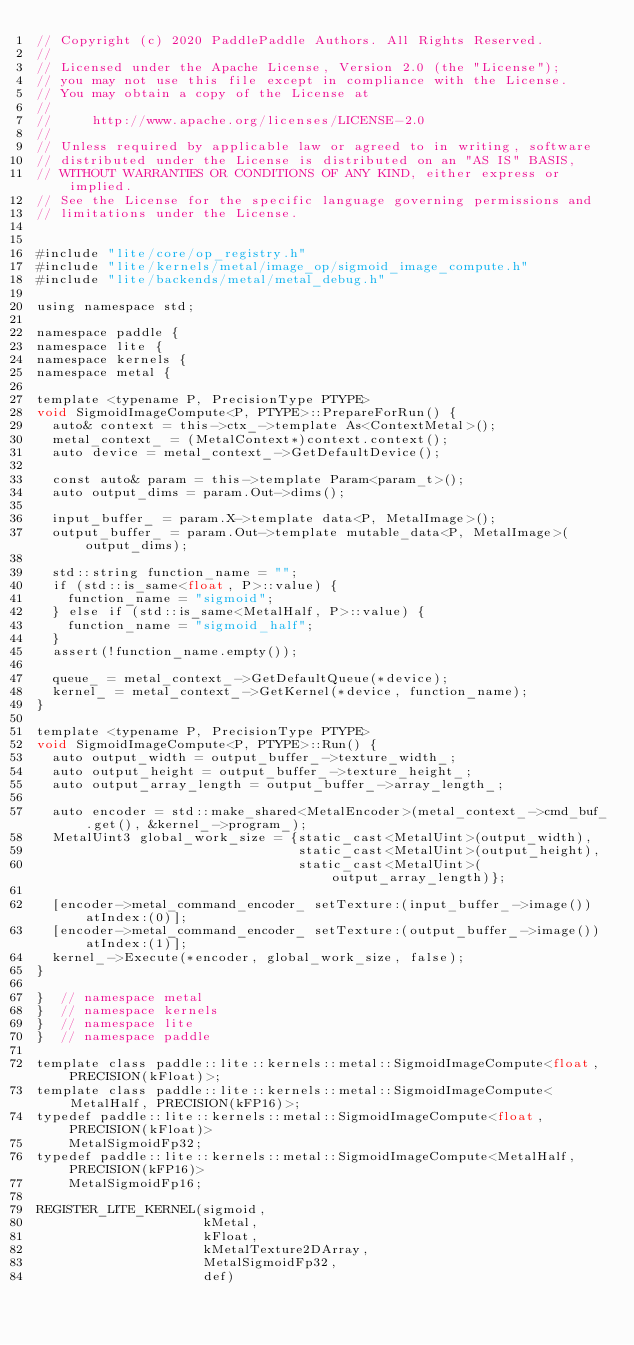<code> <loc_0><loc_0><loc_500><loc_500><_ObjectiveC_>// Copyright (c) 2020 PaddlePaddle Authors. All Rights Reserved.
//
// Licensed under the Apache License, Version 2.0 (the "License");
// you may not use this file except in compliance with the License.
// You may obtain a copy of the License at
//
//     http://www.apache.org/licenses/LICENSE-2.0
//
// Unless required by applicable law or agreed to in writing, software
// distributed under the License is distributed on an "AS IS" BASIS,
// WITHOUT WARRANTIES OR CONDITIONS OF ANY KIND, either express or implied.
// See the License for the specific language governing permissions and
// limitations under the License.


#include "lite/core/op_registry.h"
#include "lite/kernels/metal/image_op/sigmoid_image_compute.h"
#include "lite/backends/metal/metal_debug.h"

using namespace std;

namespace paddle {
namespace lite {
namespace kernels {
namespace metal {

template <typename P, PrecisionType PTYPE>
void SigmoidImageCompute<P, PTYPE>::PrepareForRun() {
  auto& context = this->ctx_->template As<ContextMetal>();
  metal_context_ = (MetalContext*)context.context();
  auto device = metal_context_->GetDefaultDevice();

  const auto& param = this->template Param<param_t>();
  auto output_dims = param.Out->dims();

  input_buffer_ = param.X->template data<P, MetalImage>();
  output_buffer_ = param.Out->template mutable_data<P, MetalImage>(output_dims);

  std::string function_name = "";
  if (std::is_same<float, P>::value) {
    function_name = "sigmoid";
  } else if (std::is_same<MetalHalf, P>::value) {
    function_name = "sigmoid_half";
  }
  assert(!function_name.empty());

  queue_ = metal_context_->GetDefaultQueue(*device);
  kernel_ = metal_context_->GetKernel(*device, function_name);
}

template <typename P, PrecisionType PTYPE>
void SigmoidImageCompute<P, PTYPE>::Run() {
  auto output_width = output_buffer_->texture_width_;
  auto output_height = output_buffer_->texture_height_;
  auto output_array_length = output_buffer_->array_length_;

  auto encoder = std::make_shared<MetalEncoder>(metal_context_->cmd_buf_.get(), &kernel_->program_);
  MetalUint3 global_work_size = {static_cast<MetalUint>(output_width),
                                 static_cast<MetalUint>(output_height),
                                 static_cast<MetalUint>(output_array_length)};

  [encoder->metal_command_encoder_ setTexture:(input_buffer_->image()) atIndex:(0)];
  [encoder->metal_command_encoder_ setTexture:(output_buffer_->image()) atIndex:(1)];
  kernel_->Execute(*encoder, global_work_size, false);
}

}  // namespace metal
}  // namespace kernels
}  // namespace lite
}  // namespace paddle

template class paddle::lite::kernels::metal::SigmoidImageCompute<float, PRECISION(kFloat)>;
template class paddle::lite::kernels::metal::SigmoidImageCompute<MetalHalf, PRECISION(kFP16)>;
typedef paddle::lite::kernels::metal::SigmoidImageCompute<float, PRECISION(kFloat)>
    MetalSigmoidFp32;
typedef paddle::lite::kernels::metal::SigmoidImageCompute<MetalHalf, PRECISION(kFP16)>
    MetalSigmoidFp16;

REGISTER_LITE_KERNEL(sigmoid,
                     kMetal,
                     kFloat,
                     kMetalTexture2DArray,
                     MetalSigmoidFp32,
                     def)</code> 